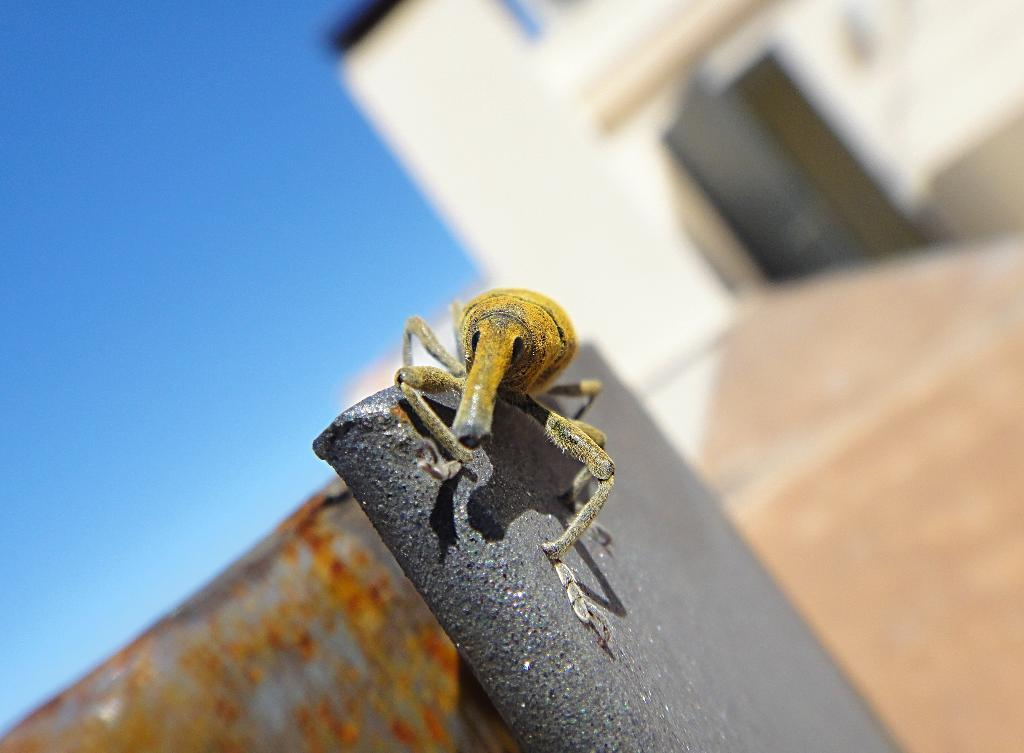What is present on the wall in the image? There is an insect on the wall in the image. Where is the insect located in relation to the house? The insect is on a wall in the image, and there is a house in the background. What type of drink is the insect holding in its hands in the image? There is no drink present in the image, and insects do not have hands. 